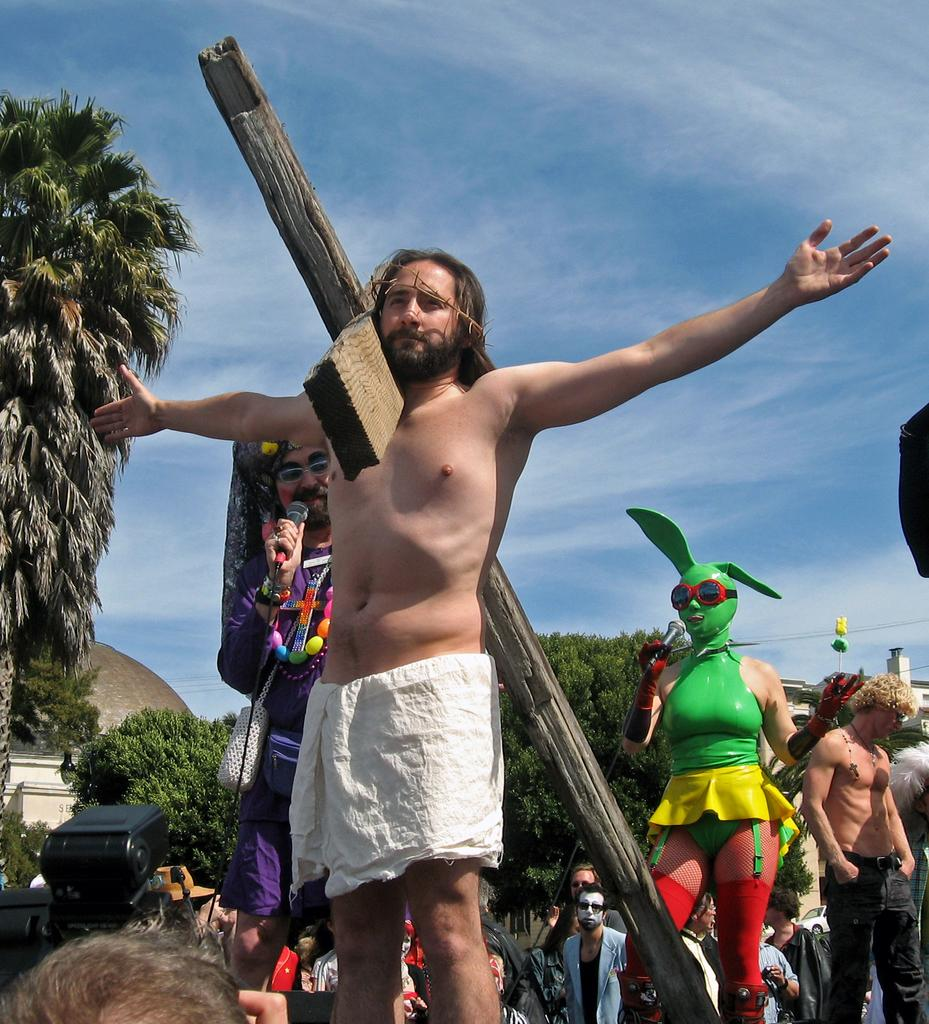How many people are in the image? There is a group of people in the image. Can you describe the woman in the group? The woman in the group is wearing a mask and holding a microphone. What type of natural environment is visible in the image? There are trees in the image, and the sky is visible in the background. What is the condition of the sky in the image? Clouds are present in the sky. How many cars are parked near the trees in the image? There are no cars present in the image; it features a group of people, trees, and a sky with clouds. What type of property is visible in the image? There is no property visible in the image; it features a group of people, trees, and a sky with clouds. 